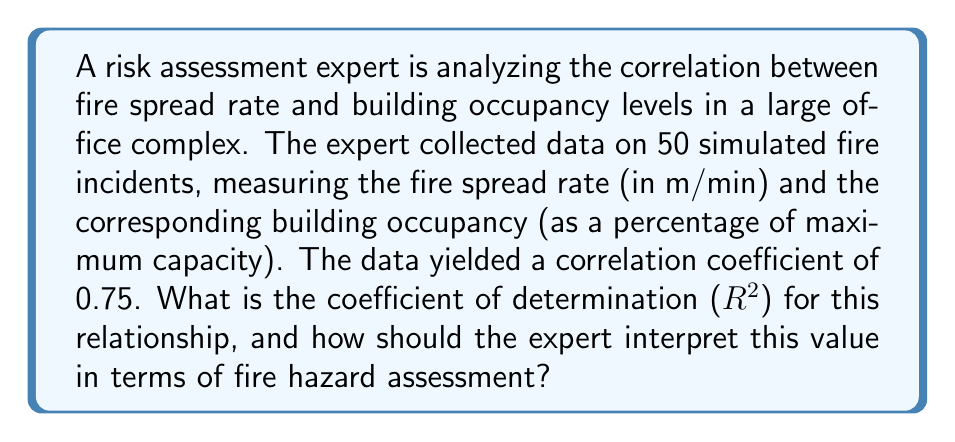Teach me how to tackle this problem. To solve this problem, we'll follow these steps:

1. Recall the relationship between correlation coefficient (r) and coefficient of determination ($R^2$):
   
   $$R^2 = r^2$$

2. Given correlation coefficient:
   
   $r = 0.75$

3. Calculate $R^2$:
   
   $$R^2 = (0.75)^2 = 0.5625$$

4. Interpretation:
   - $R^2$ ranges from 0 to 1, where 1 indicates a perfect fit.
   - $R^2 = 0.5625$ means that approximately 56.25% of the variance in fire spread rate can be explained by changes in building occupancy levels.
   - This suggests a moderate to strong relationship between the variables.
   - For fire hazard assessment:
     a. The expert should consider occupancy levels as a significant factor in fire spread predictions.
     b. However, other factors (accounting for the remaining 43.75% of variance) also play important roles in fire spread.
     c. The expert should recommend occupancy control measures as part of fire prevention strategies.
     d. Additional factors influencing fire spread should be investigated for comprehensive risk assessment.
Answer: $R^2 = 0.5625$; 56.25% of fire spread rate variance explained by occupancy levels, indicating a moderate to strong relationship requiring consideration in risk assessment and prevention strategies. 